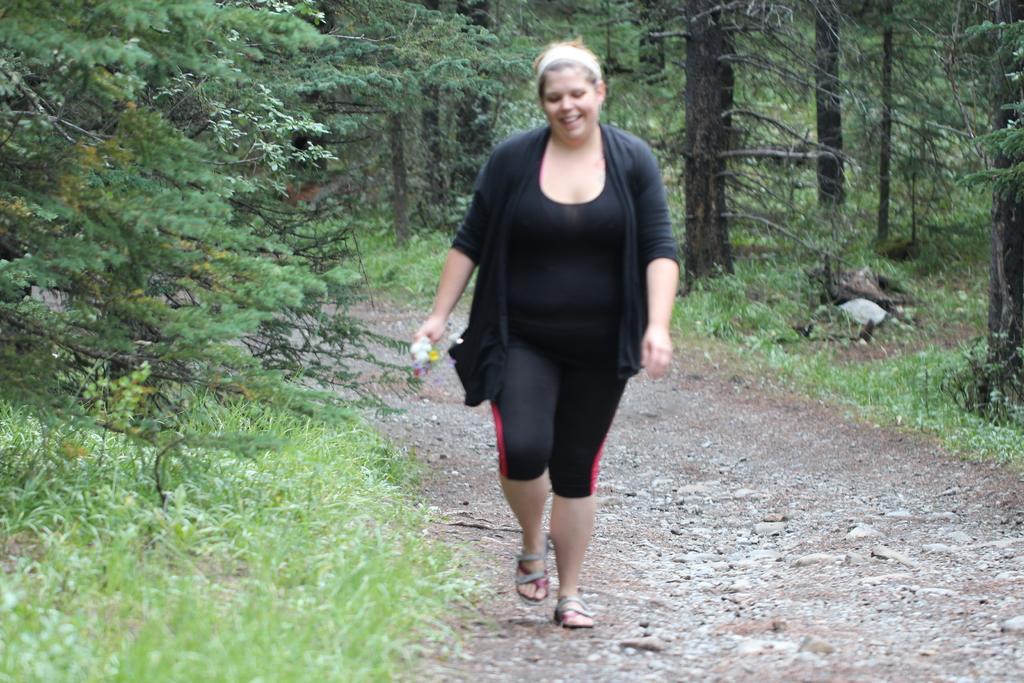Could you give a brief overview of what you see in this image? There is a woman walking and holding an object and we can see grass. In the background we can see trees. 